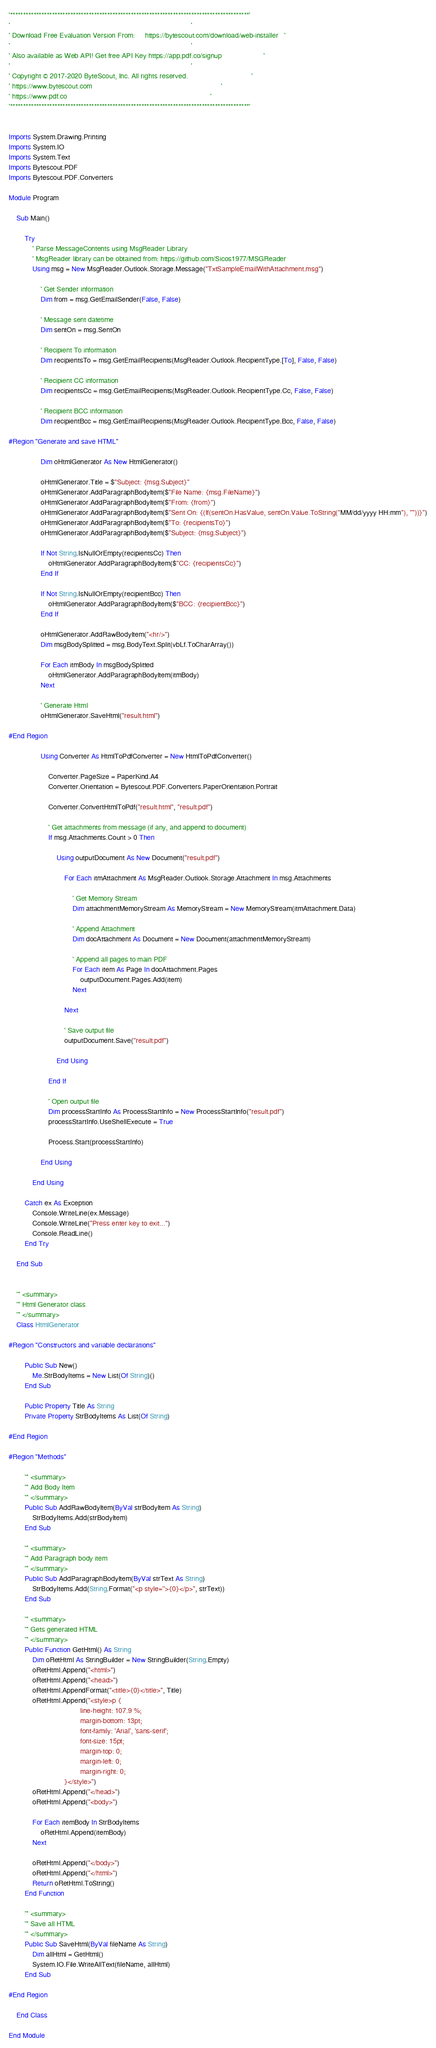<code> <loc_0><loc_0><loc_500><loc_500><_VisualBasic_>'*******************************************************************************************'
'                                                                                           '
' Download Free Evaluation Version From:     https://bytescout.com/download/web-installer   '
'                                                                                           '
' Also available as Web API! Get free API Key https://app.pdf.co/signup                     '
'                                                                                           '
' Copyright © 2017-2020 ByteScout, Inc. All rights reserved.                                '
' https://www.bytescout.com                                                                 '
' https://www.pdf.co                                                                        '
'*******************************************************************************************'


Imports System.Drawing.Printing
Imports System.IO
Imports System.Text
Imports Bytescout.PDF
Imports Bytescout.PDF.Converters

Module Program

    Sub Main()

        Try
            ' Parse MessageContents using MsgReader Library
            ' MsgReader library can be obtained from: https://github.com/Sicos1977/MSGReader
            Using msg = New MsgReader.Outlook.Storage.Message("TxtSampleEmailWithAttachment.msg")

                ' Get Sender information
                Dim from = msg.GetEmailSender(False, False)

                ' Message sent datetime
                Dim sentOn = msg.SentOn

                ' Recipient To information
                Dim recipientsTo = msg.GetEmailRecipients(MsgReader.Outlook.RecipientType.[To], False, False)

                ' Recipient CC information
                Dim recipientsCc = msg.GetEmailRecipients(MsgReader.Outlook.RecipientType.Cc, False, False)

                ' Recipient BCC information
                Dim recipientBcc = msg.GetEmailRecipients(MsgReader.Outlook.RecipientType.Bcc, False, False)

#Region "Generate and save HTML"

                Dim oHtmlGenerator As New HtmlGenerator()

                oHtmlGenerator.Title = $"Subject: {msg.Subject}"
                oHtmlGenerator.AddParagraphBodyItem($"File Name: {msg.FileName}")
                oHtmlGenerator.AddParagraphBodyItem($"From: {from}")
                oHtmlGenerator.AddParagraphBodyItem($"Sent On: {(If(sentOn.HasValue, sentOn.Value.ToString("MM/dd/yyyy HH:mm"), ""))}")
                oHtmlGenerator.AddParagraphBodyItem($"To: {recipientsTo}")
                oHtmlGenerator.AddParagraphBodyItem($"Subject: {msg.Subject}")

                If Not String.IsNullOrEmpty(recipientsCc) Then
                    oHtmlGenerator.AddParagraphBodyItem($"CC: {recipientsCc}")
                End If

                If Not String.IsNullOrEmpty(recipientBcc) Then
                    oHtmlGenerator.AddParagraphBodyItem($"BCC: {recipientBcc}")
                End If

                oHtmlGenerator.AddRawBodyItem("<hr/>")
                Dim msgBodySplitted = msg.BodyText.Split(vbLf.ToCharArray())

                For Each itmBody In msgBodySplitted
                    oHtmlGenerator.AddParagraphBodyItem(itmBody)
                Next

                ' Generate Html
                oHtmlGenerator.SaveHtml("result.html")

#End Region

                Using Converter As HtmlToPdfConverter = New HtmlToPdfConverter()

                    Converter.PageSize = PaperKind.A4
                    Converter.Orientation = Bytescout.PDF.Converters.PaperOrientation.Portrait

                    Converter.ConvertHtmlToPdf("result.html", "result.pdf")

                    ' Get attachments from message (if any, and append to document)
                    If msg.Attachments.Count > 0 Then

                        Using outputDocument As New Document("result.pdf")

                            For Each itmAttachment As MsgReader.Outlook.Storage.Attachment In msg.Attachments

                                ' Get Memory Stream
                                Dim attachmentMemoryStream As MemoryStream = New MemoryStream(itmAttachment.Data)

                                ' Append Attachment
                                Dim docAttachment As Document = New Document(attachmentMemoryStream)

                                ' Append all pages to main PDF
                                For Each item As Page In docAttachment.Pages
                                    outputDocument.Pages.Add(item)
                                Next

                            Next

                            ' Save output file
                            outputDocument.Save("result.pdf")

                        End Using

                    End If

                    ' Open output file
                    Dim processStartInfo As ProcessStartInfo = New ProcessStartInfo("result.pdf")
                    processStartInfo.UseShellExecute = True

                    Process.Start(processStartInfo)

                End Using

            End Using

        Catch ex As Exception
            Console.WriteLine(ex.Message)
            Console.WriteLine("Press enter key to exit...")
            Console.ReadLine()
        End Try

    End Sub


    ''' <summary>
    ''' Html Generator class
    ''' </summary>
    Class HtmlGenerator

#Region "Constructors and variable declarations"

        Public Sub New()
            Me.StrBodyItems = New List(Of String)()
        End Sub

        Public Property Title As String
        Private Property StrBodyItems As List(Of String)

#End Region

#Region "Methods"

        ''' <summary>
        ''' Add Body Item
        ''' </summary>
        Public Sub AddRawBodyItem(ByVal strBodyItem As String)
            StrBodyItems.Add(strBodyItem)
        End Sub

        ''' <summary>
        ''' Add Paragraph body item
        ''' </summary>
        Public Sub AddParagraphBodyItem(ByVal strText As String)
            StrBodyItems.Add(String.Format("<p style=''>{0}</p>", strText))
        End Sub

        ''' <summary>
        ''' Gets generated HTML
        ''' </summary>
        Public Function GetHtml() As String
            Dim oRetHtml As StringBuilder = New StringBuilder(String.Empty)
            oRetHtml.Append("<html>")
            oRetHtml.Append("<head>")
            oRetHtml.AppendFormat("<title>{0}</title>", Title)
            oRetHtml.Append("<style>p {
                                    line-height: 107.9 %;
                                    margin-bottom: 13pt;
                                    font-family: 'Arial', 'sans-serif';
                                    font-size: 15pt;
                                    margin-top: 0;
                                    margin-left: 0;
                                    margin-right: 0;
                            }</style>")
            oRetHtml.Append("</head>")
            oRetHtml.Append("<body>")

            For Each itemBody In StrBodyItems
                oRetHtml.Append(itemBody)
            Next

            oRetHtml.Append("</body>")
            oRetHtml.Append("</html>")
            Return oRetHtml.ToString()
        End Function

        ''' <summary>
        ''' Save all HTML
        ''' </summary>
        Public Sub SaveHtml(ByVal fileName As String)
            Dim allHtml = GetHtml()
            System.IO.File.WriteAllText(fileName, allHtml)
        End Sub

#End Region

    End Class

End Module
</code> 